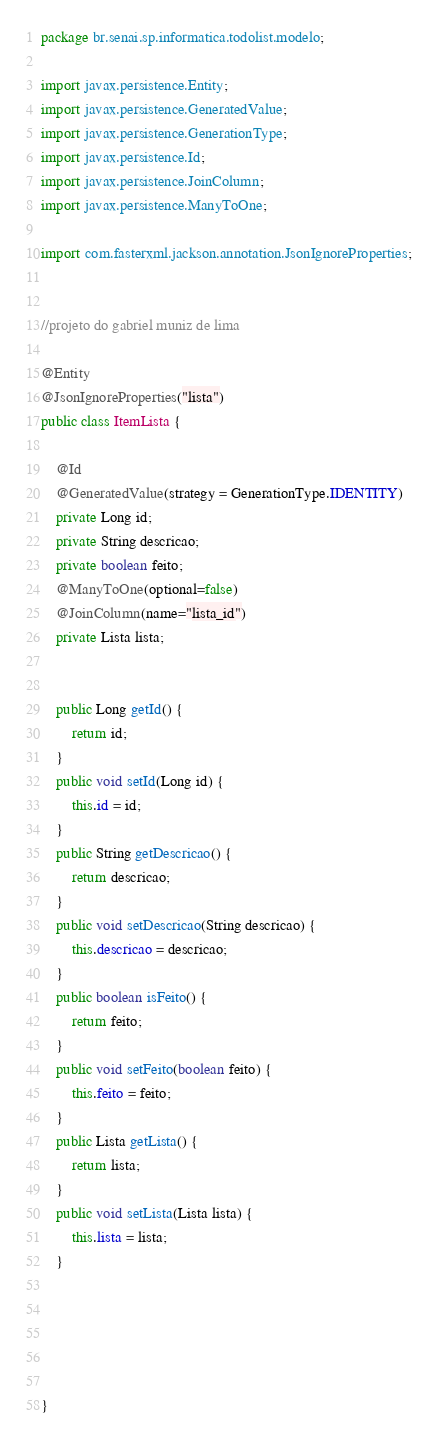<code> <loc_0><loc_0><loc_500><loc_500><_Java_>package br.senai.sp.informatica.todolist.modelo;

import javax.persistence.Entity;
import javax.persistence.GeneratedValue;
import javax.persistence.GenerationType;
import javax.persistence.Id;
import javax.persistence.JoinColumn;
import javax.persistence.ManyToOne;

import com.fasterxml.jackson.annotation.JsonIgnoreProperties;

 
//projeto do gabriel muniz de lima

@Entity	
@JsonIgnoreProperties("lista")
public class ItemLista {
	
	@Id
	@GeneratedValue(strategy = GenerationType.IDENTITY)
	private Long id;
	private String descricao;
	private boolean feito;
	@ManyToOne(optional=false)
	@JoinColumn(name="lista_id")
	private Lista lista;
	
	
	public Long getId() {
		return id;
	}
	public void setId(Long id) {
		this.id = id;
	}
	public String getDescricao() {
		return descricao;
	}
	public void setDescricao(String descricao) {
		this.descricao = descricao;
	}
	public boolean isFeito() {
		return feito;
	}
	public void setFeito(boolean feito) {
		this.feito = feito;
	}
	public Lista getLista() {
		return lista;
	}
	public void setLista(Lista lista) {
		this.lista = lista;
	}
	
	
	
	

}
</code> 